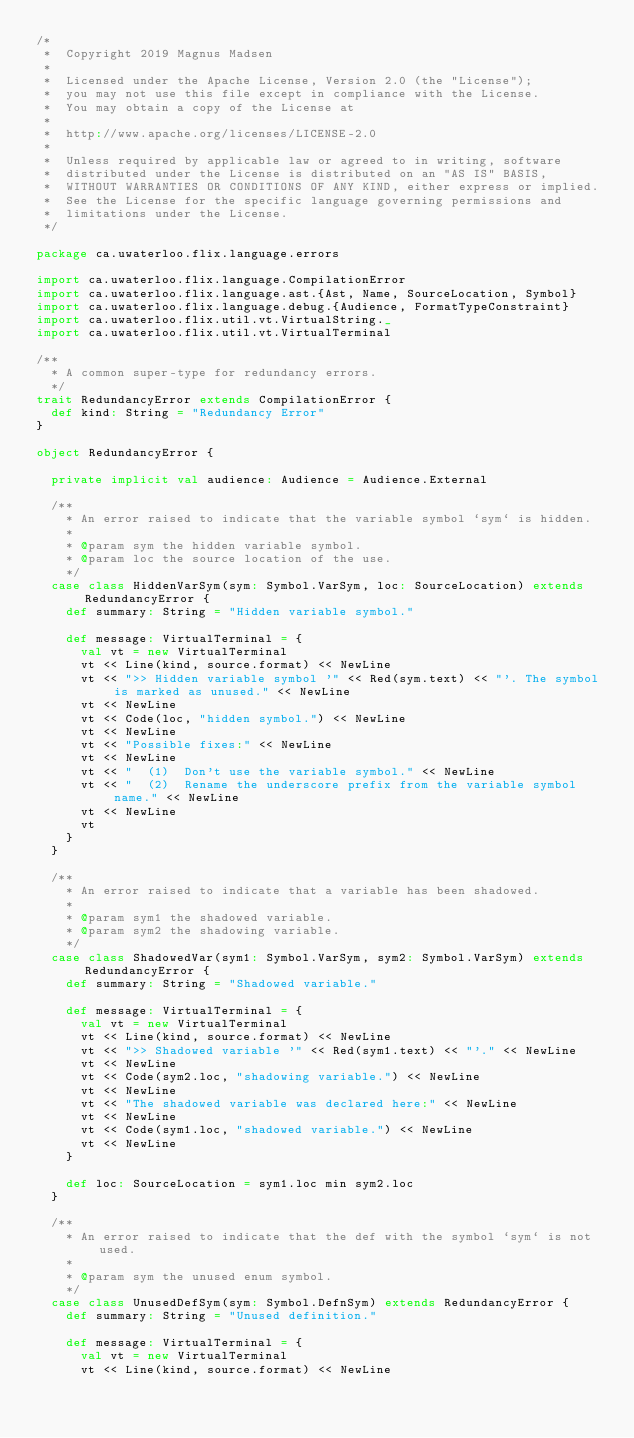Convert code to text. <code><loc_0><loc_0><loc_500><loc_500><_Scala_>/*
 *  Copyright 2019 Magnus Madsen
 *
 *  Licensed under the Apache License, Version 2.0 (the "License");
 *  you may not use this file except in compliance with the License.
 *  You may obtain a copy of the License at
 *
 *  http://www.apache.org/licenses/LICENSE-2.0
 *
 *  Unless required by applicable law or agreed to in writing, software
 *  distributed under the License is distributed on an "AS IS" BASIS,
 *  WITHOUT WARRANTIES OR CONDITIONS OF ANY KIND, either express or implied.
 *  See the License for the specific language governing permissions and
 *  limitations under the License.
 */

package ca.uwaterloo.flix.language.errors

import ca.uwaterloo.flix.language.CompilationError
import ca.uwaterloo.flix.language.ast.{Ast, Name, SourceLocation, Symbol}
import ca.uwaterloo.flix.language.debug.{Audience, FormatTypeConstraint}
import ca.uwaterloo.flix.util.vt.VirtualString._
import ca.uwaterloo.flix.util.vt.VirtualTerminal

/**
  * A common super-type for redundancy errors.
  */
trait RedundancyError extends CompilationError {
  def kind: String = "Redundancy Error"
}

object RedundancyError {

  private implicit val audience: Audience = Audience.External

  /**
    * An error raised to indicate that the variable symbol `sym` is hidden.
    *
    * @param sym the hidden variable symbol.
    * @param loc the source location of the use.
    */
  case class HiddenVarSym(sym: Symbol.VarSym, loc: SourceLocation) extends RedundancyError {
    def summary: String = "Hidden variable symbol."

    def message: VirtualTerminal = {
      val vt = new VirtualTerminal
      vt << Line(kind, source.format) << NewLine
      vt << ">> Hidden variable symbol '" << Red(sym.text) << "'. The symbol is marked as unused." << NewLine
      vt << NewLine
      vt << Code(loc, "hidden symbol.") << NewLine
      vt << NewLine
      vt << "Possible fixes:" << NewLine
      vt << NewLine
      vt << "  (1)  Don't use the variable symbol." << NewLine
      vt << "  (2)  Rename the underscore prefix from the variable symbol name." << NewLine
      vt << NewLine
      vt
    }
  }

  /**
    * An error raised to indicate that a variable has been shadowed.
    *
    * @param sym1 the shadowed variable.
    * @param sym2 the shadowing variable.
    */
  case class ShadowedVar(sym1: Symbol.VarSym, sym2: Symbol.VarSym) extends RedundancyError {
    def summary: String = "Shadowed variable."

    def message: VirtualTerminal = {
      val vt = new VirtualTerminal
      vt << Line(kind, source.format) << NewLine
      vt << ">> Shadowed variable '" << Red(sym1.text) << "'." << NewLine
      vt << NewLine
      vt << Code(sym2.loc, "shadowing variable.") << NewLine
      vt << NewLine
      vt << "The shadowed variable was declared here:" << NewLine
      vt << NewLine
      vt << Code(sym1.loc, "shadowed variable.") << NewLine
      vt << NewLine
    }

    def loc: SourceLocation = sym1.loc min sym2.loc
  }

  /**
    * An error raised to indicate that the def with the symbol `sym` is not used.
    *
    * @param sym the unused enum symbol.
    */
  case class UnusedDefSym(sym: Symbol.DefnSym) extends RedundancyError {
    def summary: String = "Unused definition."

    def message: VirtualTerminal = {
      val vt = new VirtualTerminal
      vt << Line(kind, source.format) << NewLine</code> 